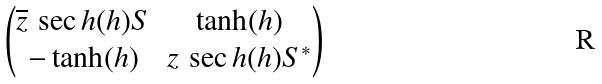<formula> <loc_0><loc_0><loc_500><loc_500>\begin{pmatrix} \overline { z } \, \sec h ( h ) S & \tanh ( h ) \\ - \tanh ( h ) & z \, \sec h ( h ) S ^ { * } \end{pmatrix}</formula> 